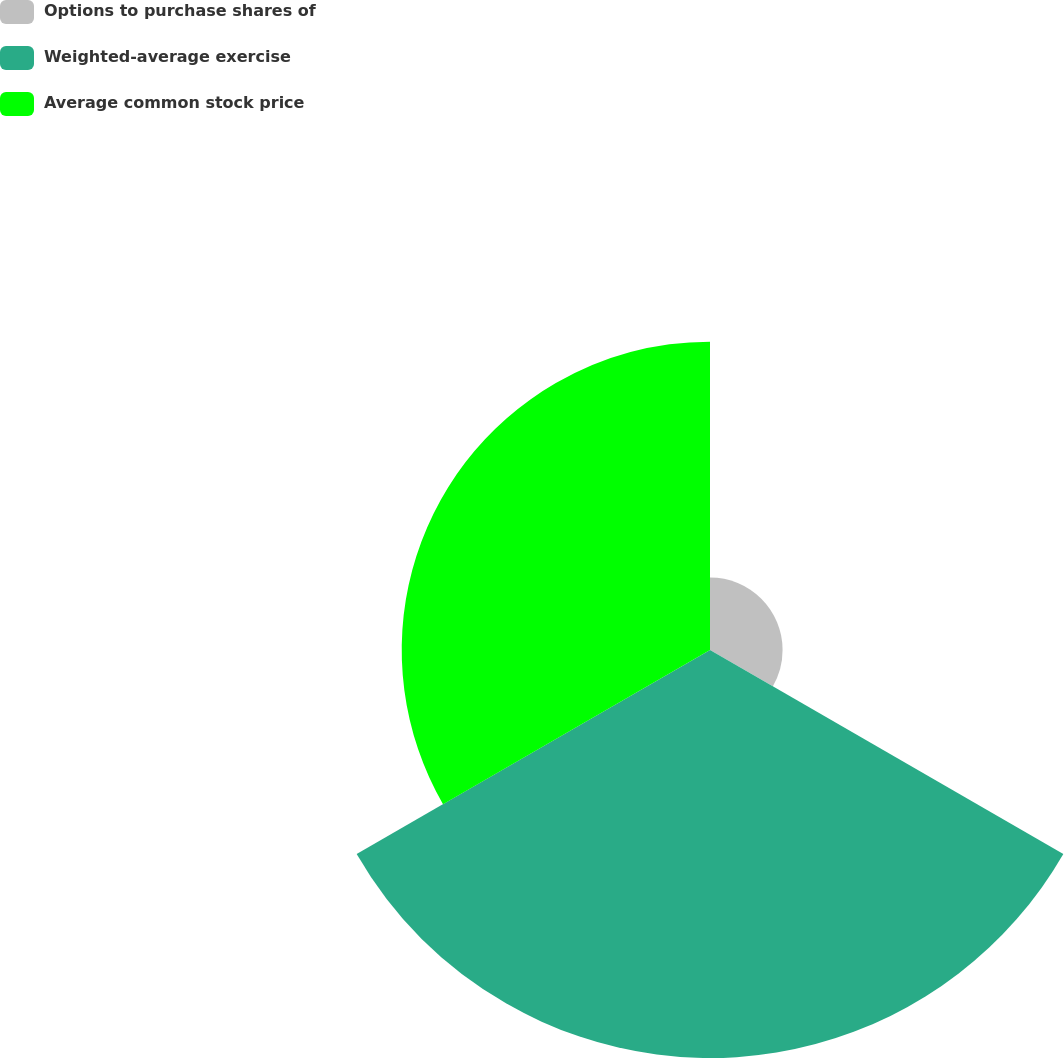Convert chart to OTSL. <chart><loc_0><loc_0><loc_500><loc_500><pie_chart><fcel>Options to purchase shares of<fcel>Weighted-average exercise<fcel>Average common stock price<nl><fcel>9.2%<fcel>51.72%<fcel>39.08%<nl></chart> 